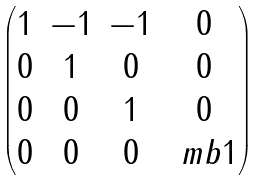<formula> <loc_0><loc_0><loc_500><loc_500>\begin{pmatrix} 1 & - 1 & - 1 & 0 \\ 0 & 1 & 0 & 0 \\ 0 & 0 & 1 & 0 \\ 0 & 0 & 0 & \ m b { 1 } \end{pmatrix}</formula> 